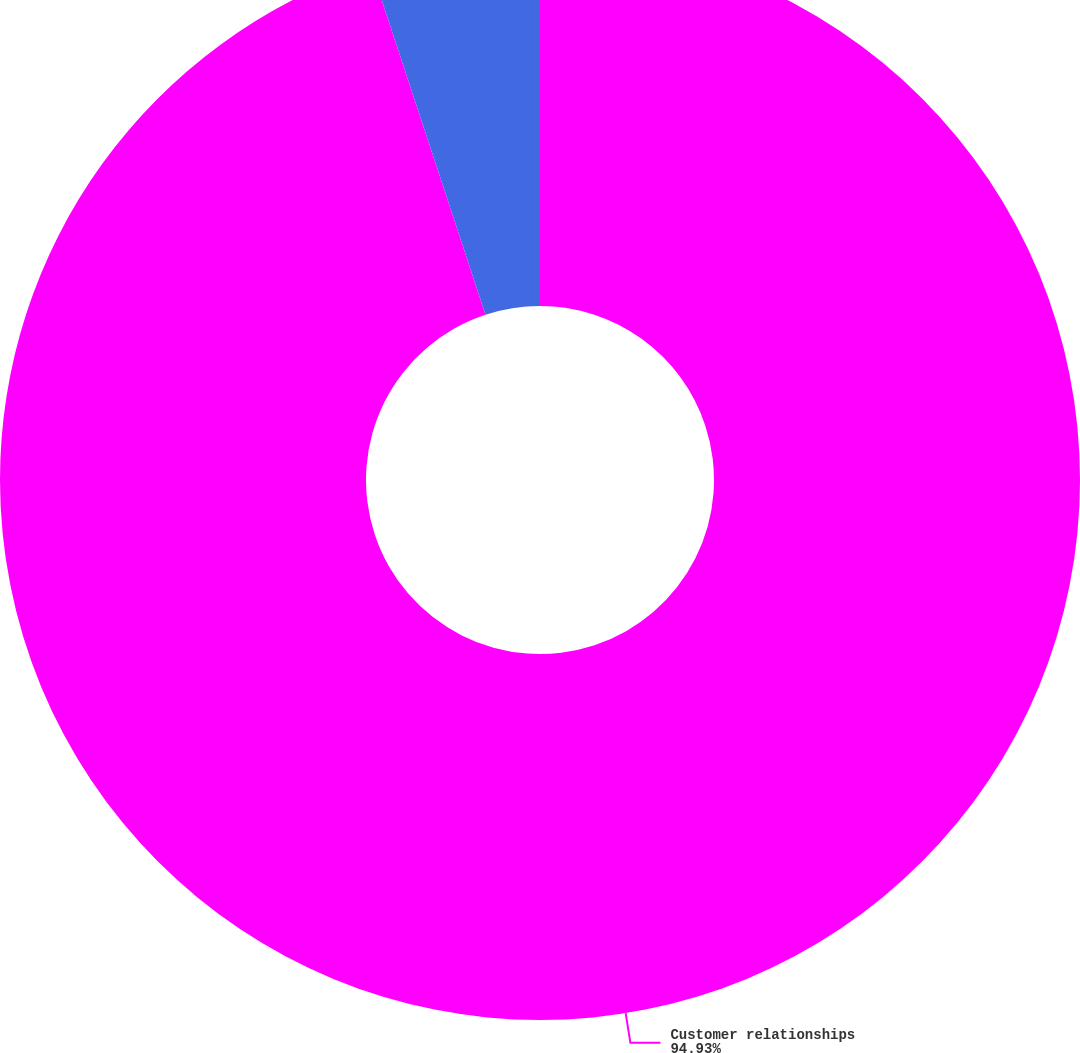Convert chart to OTSL. <chart><loc_0><loc_0><loc_500><loc_500><pie_chart><fcel>Customer relationships<fcel>Other intangible assets<nl><fcel>94.93%<fcel>5.07%<nl></chart> 